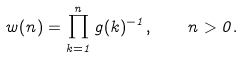<formula> <loc_0><loc_0><loc_500><loc_500>w ( n ) = \prod _ { k = 1 } ^ { n } g ( k ) ^ { - 1 } , \quad n > 0 .</formula> 